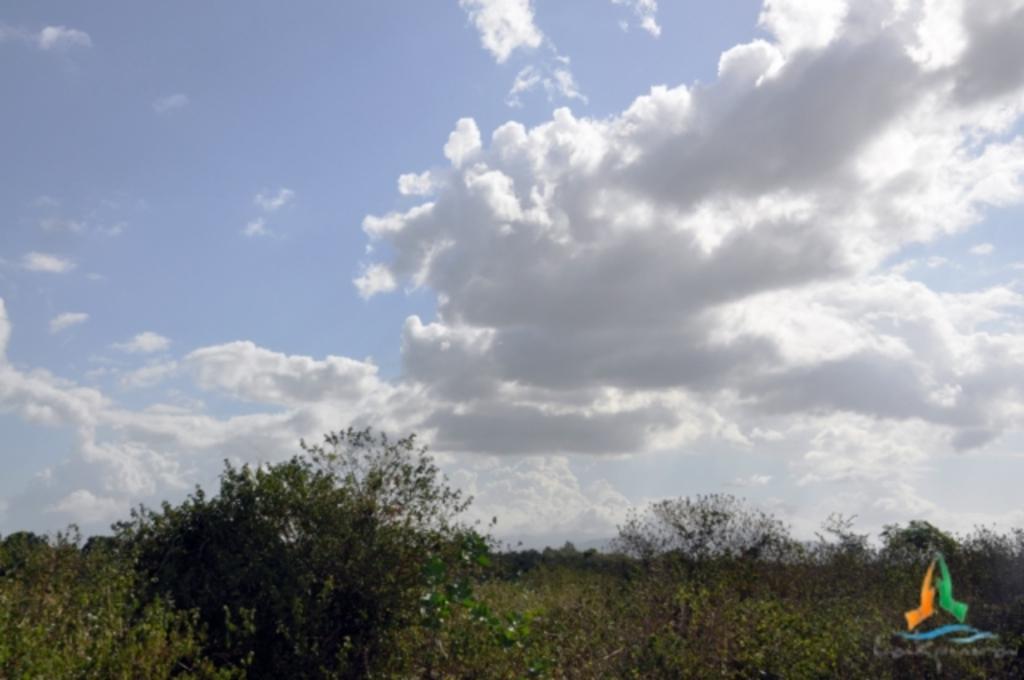Describe this image in one or two sentences. In this image we can see one image on the bottom right side of the image, some trees, bushes, plants and grass on the ground. In the background there is the cloudy sky. 